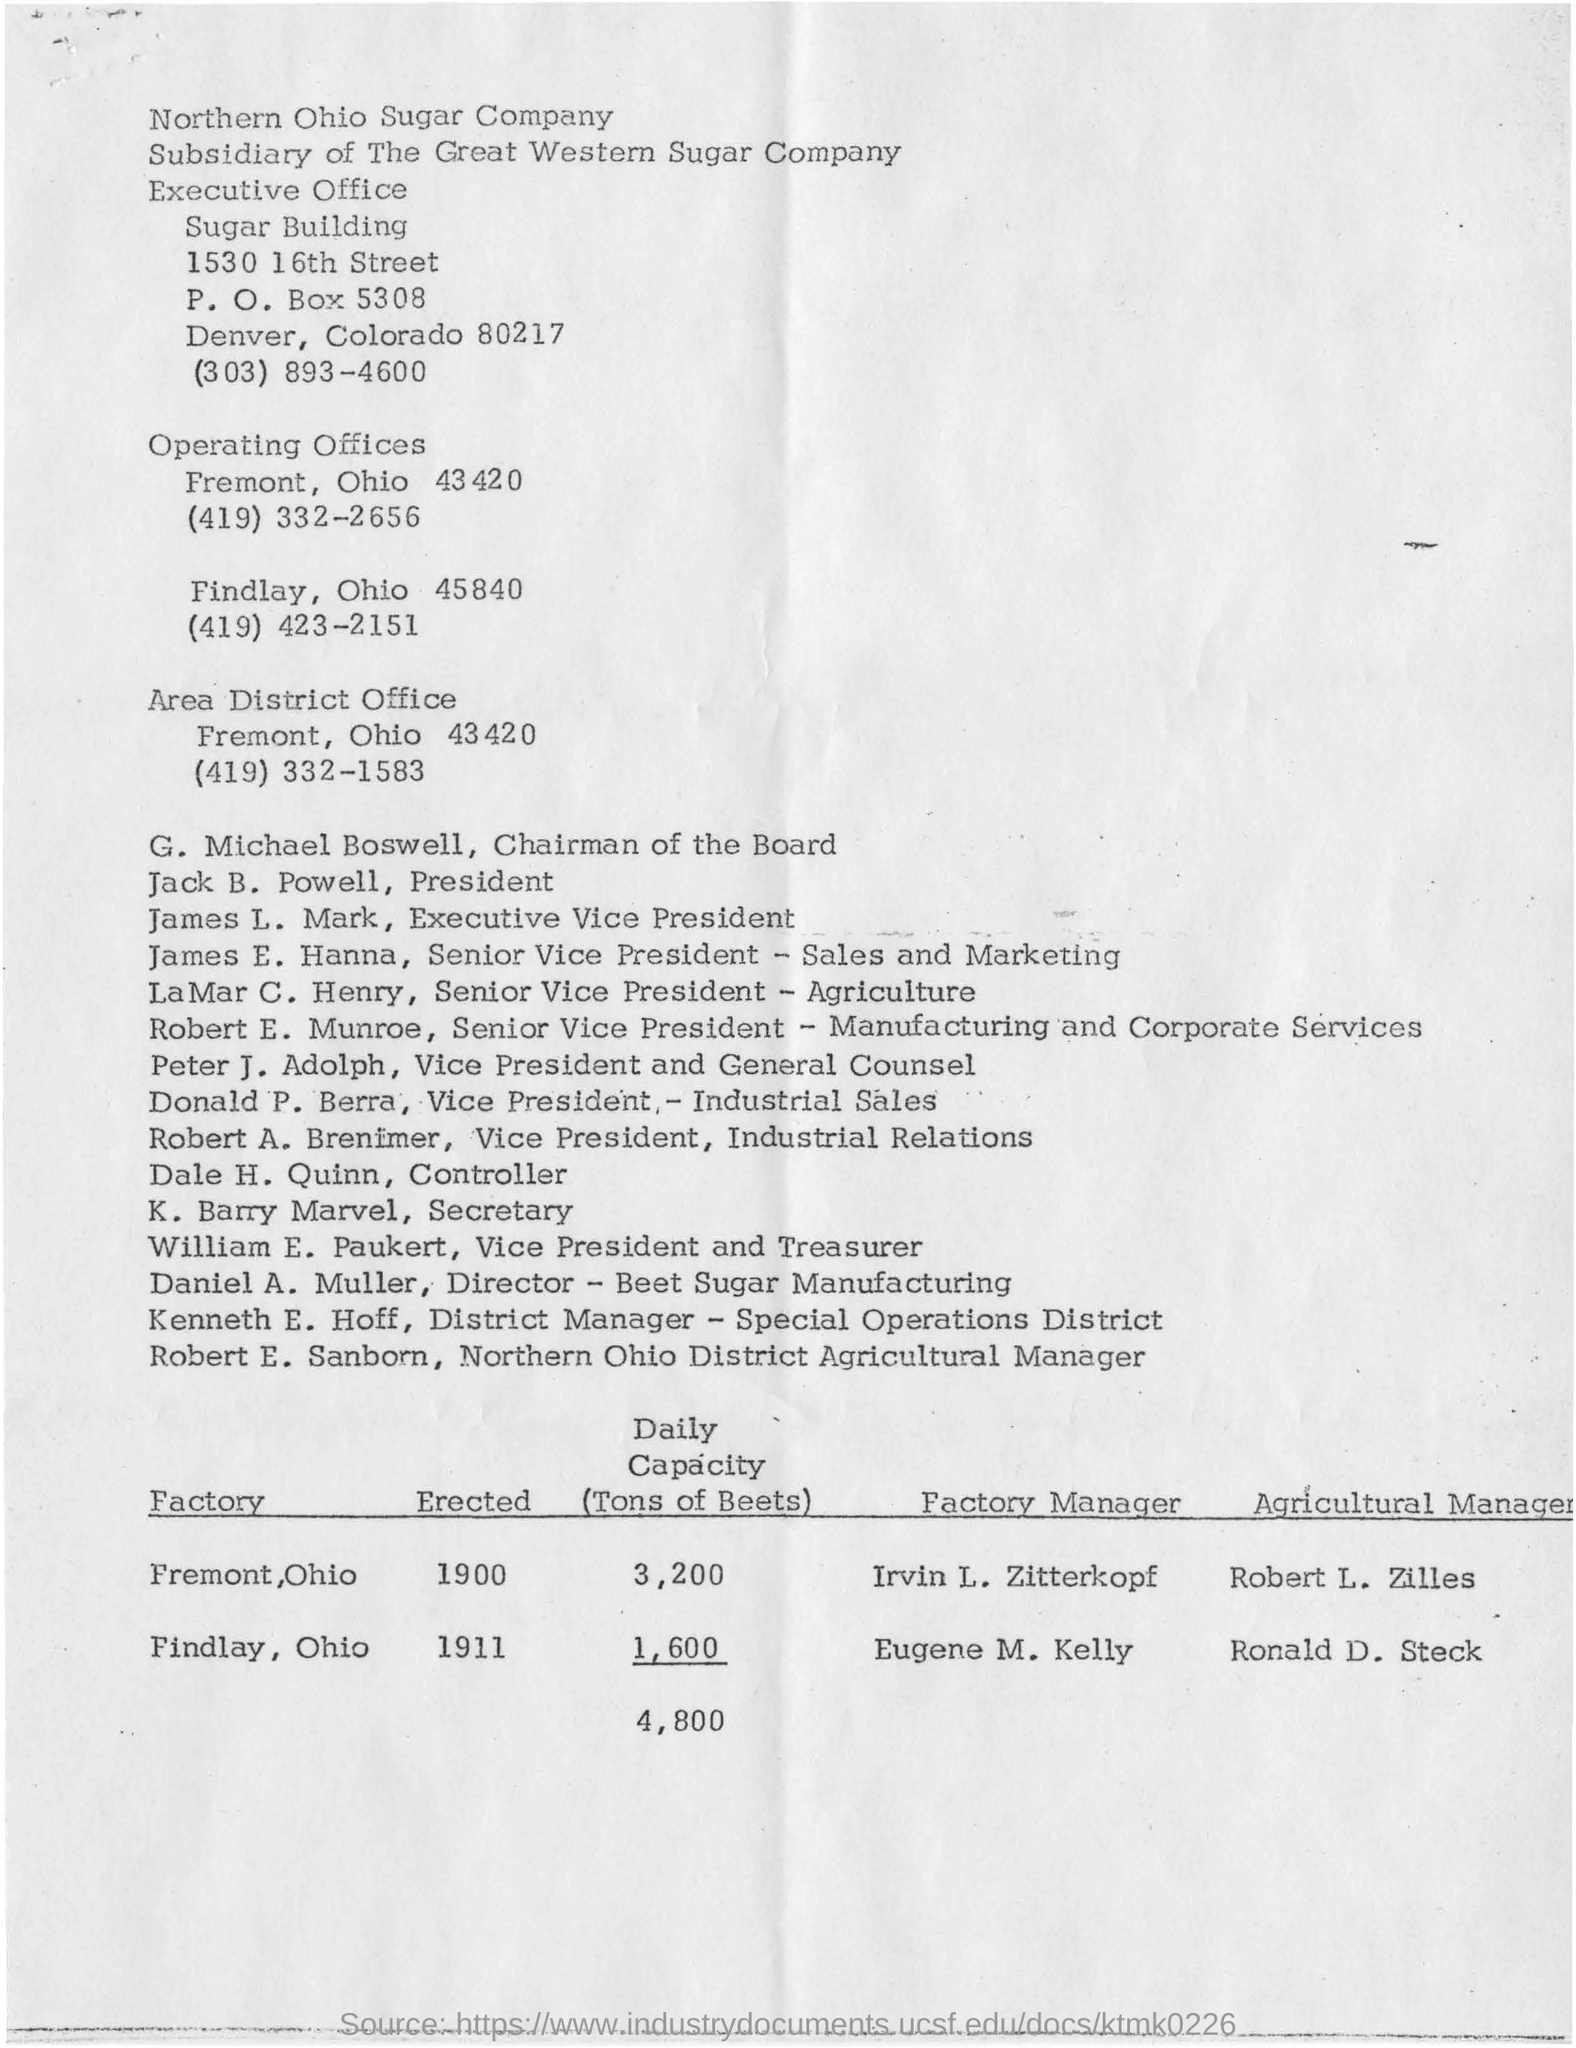Can you tell me more about the Northern Ohio Sugar Company? The Northern Ohio Sugar Company, as indicated in the image, was a subsidiary of The Great Western Sugar Company. It had its Executive Office in the Sugar Building, located at 1530 16th Street in Denver, Colorado. The document lists various executives and offices associated with the company, suggesting its significant organizational structure and operational capacity during the time the document was produced. 